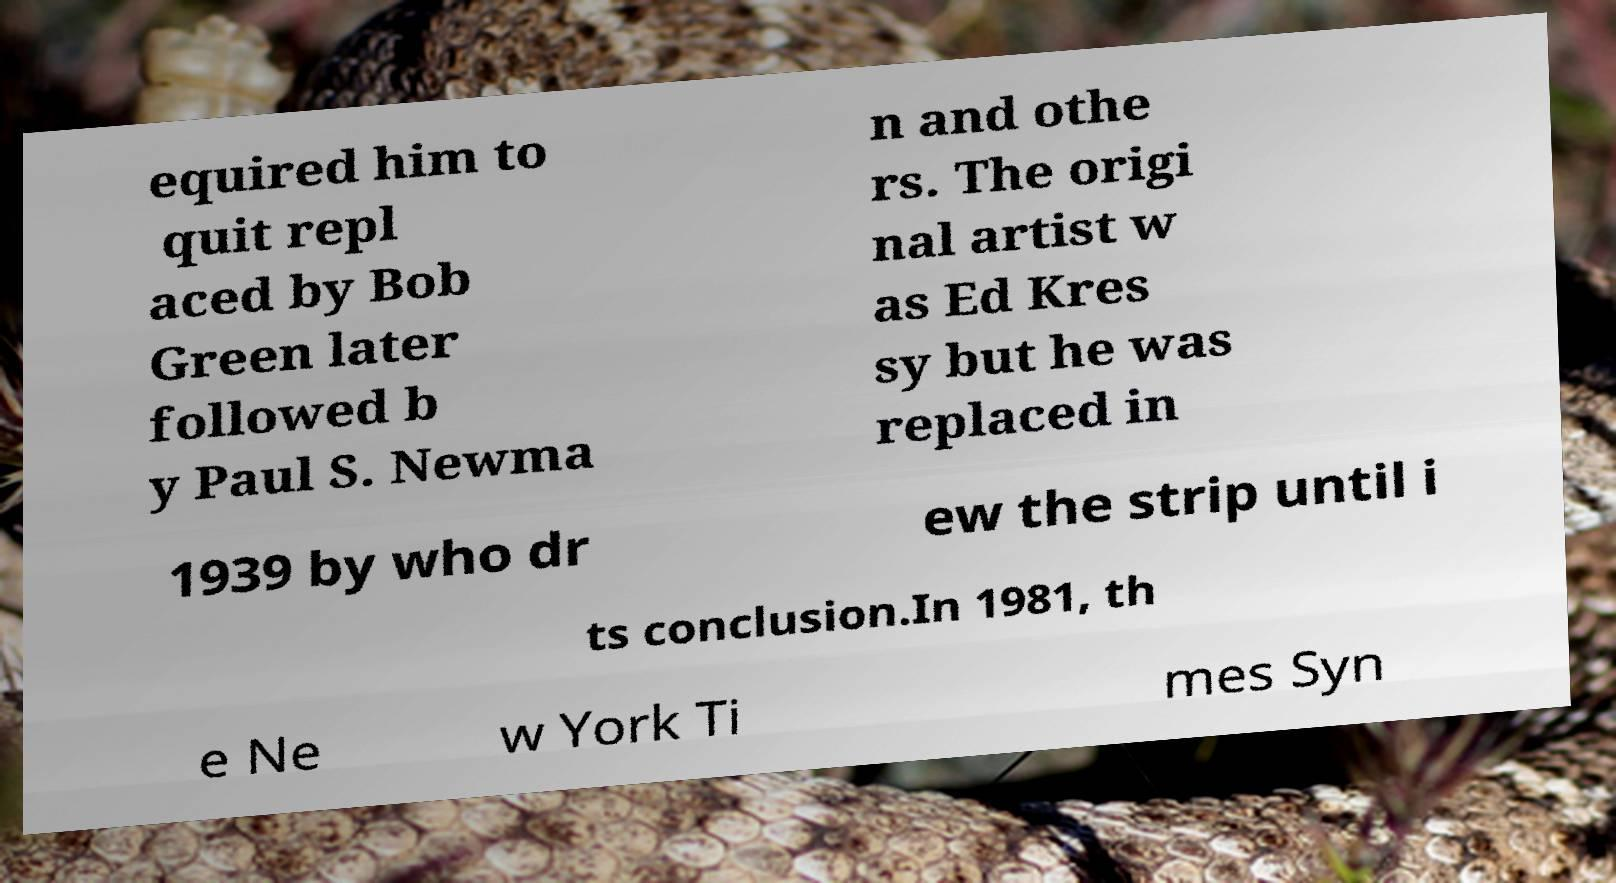Could you extract and type out the text from this image? equired him to quit repl aced by Bob Green later followed b y Paul S. Newma n and othe rs. The origi nal artist w as Ed Kres sy but he was replaced in 1939 by who dr ew the strip until i ts conclusion.In 1981, th e Ne w York Ti mes Syn 